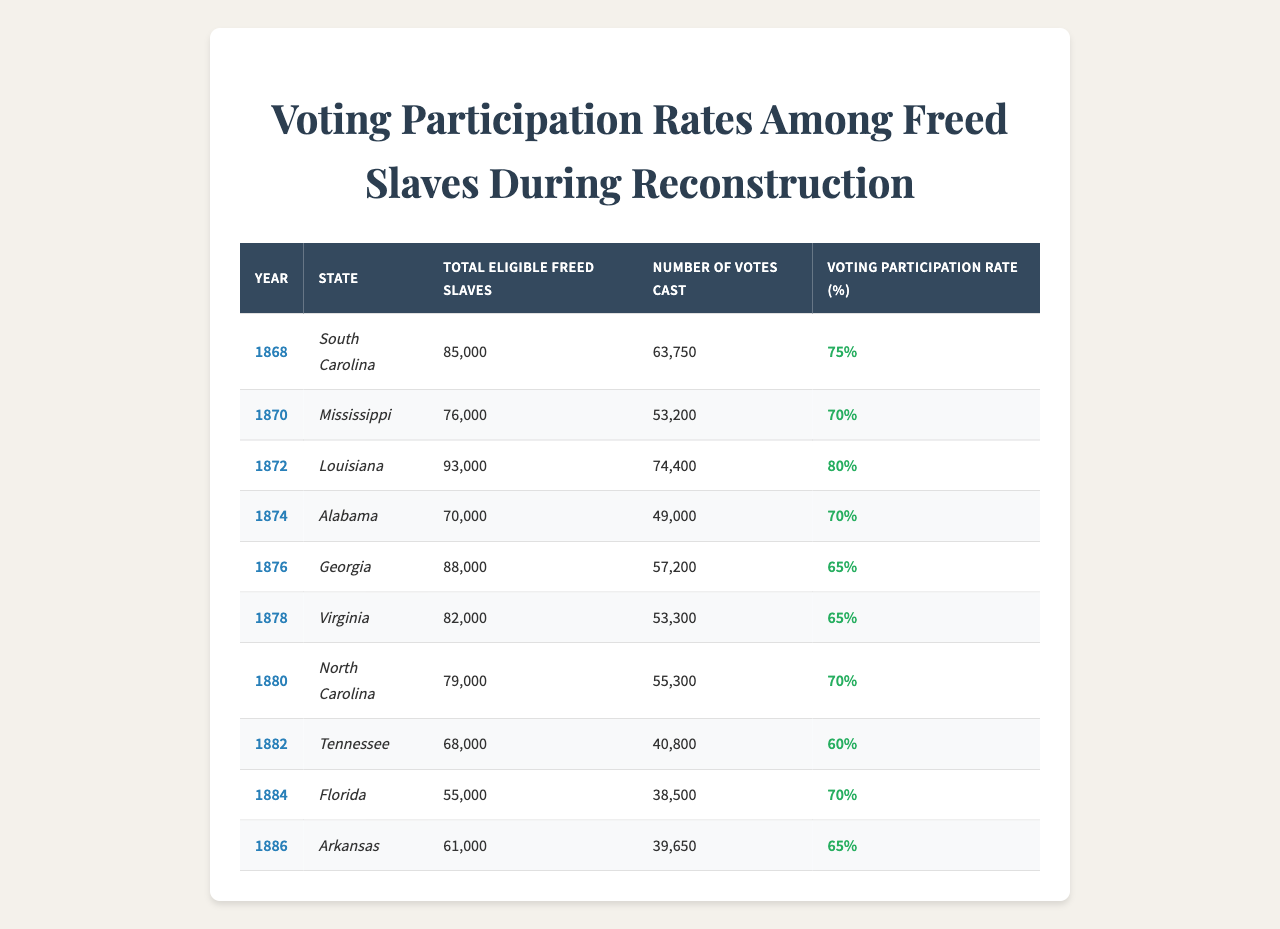What was the voting participation rate in South Carolina in 1868? The table shows that in South Carolina in 1868, the voting participation rate was 75%.
Answer: 75% Which state had the highest voting participation rate during the years shown? By examining the rates, Louisiana had the highest voting participation rate at 80% in 1872.
Answer: Louisiana, 80% What is the total number of votes cast by freed slaves in Virginia in 1878? The table indicates that the number of votes cast by freed slaves in Virginia in 1878 was 53,300.
Answer: 53,300 In which year did Alabama have a voting participation rate of 70%? The table indicates that Alabama had a voting participation rate of 70% in both 1870 and 1874.
Answer: 1870 and 1874 What was the difference in voting participation rates between Georgia in 1876 and Louisiana in 1872? The voting participation rate in Georgia in 1876 was 65%, and in Louisiana in 1872 it was 80%. The difference is 80% - 65% = 15%.
Answer: 15% Is the voting participation rate in Florida higher than that in Tennessee during the years shown? Florida had a voting participation rate of 70% in 1884 while Tennessee had a rate of 60% in 1882. Thus, Florida's rate is higher than Tennessee's.
Answer: Yes What was the average voting participation rate across all states for the year 1876? For 1876, the rates were 65% (Georgia) and no other entries for that year. The average is simply 65% as it's the only entry.
Answer: 65% If you combine the total eligible freed slaves in Mississippi and Alabama, what is the total? Mississippi had 76,000 eligible freed slaves and Alabama had 70,000 eligible freed slaves. The total is 76,000 + 70,000 = 146,000.
Answer: 146,000 Which state had the lowest number of votes cast by freed slaves, and what was that number? The table shows that Tennessee had the lowest number of votes cast at 40,800 in 1882.
Answer: Tennessee, 40,800 What was the voting participation rate in North Carolina in 1880 and how does it compare to that of Georgia in 1876? North Carolina had a voting participation rate of 70% in 1880, while Georgia had a rate of 65% in 1876. Therefore, North Carolina's rate is 5% higher than Georgia's.
Answer: North Carolina, 5% higher 